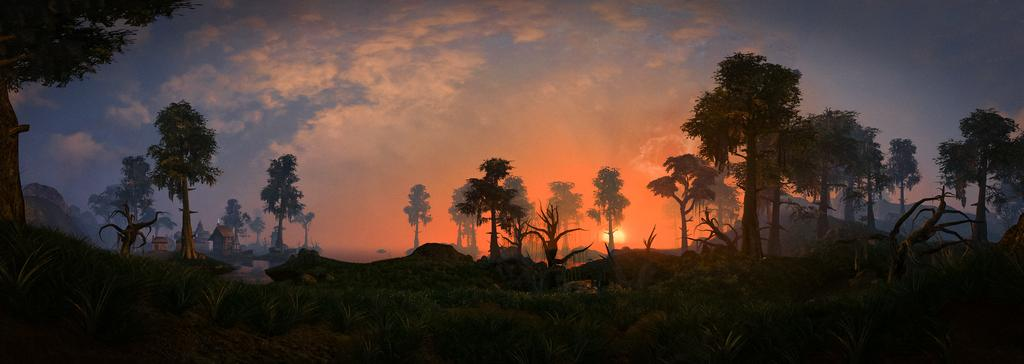What type of natural elements can be seen in the image? There are many trees and plants in the image. What type of man-made structures are present in the image? There are houses in the image. What can be seen in the background of the image? The sky is visible in the background of the image. How many eyes can be seen on the trees in the image? Trees do not have eyes, so there are no eyes visible on the trees in the image. What type of harmony is being depicted in the image? The image does not depict any specific harmony, as it primarily features trees, plants, houses, and the sky. 